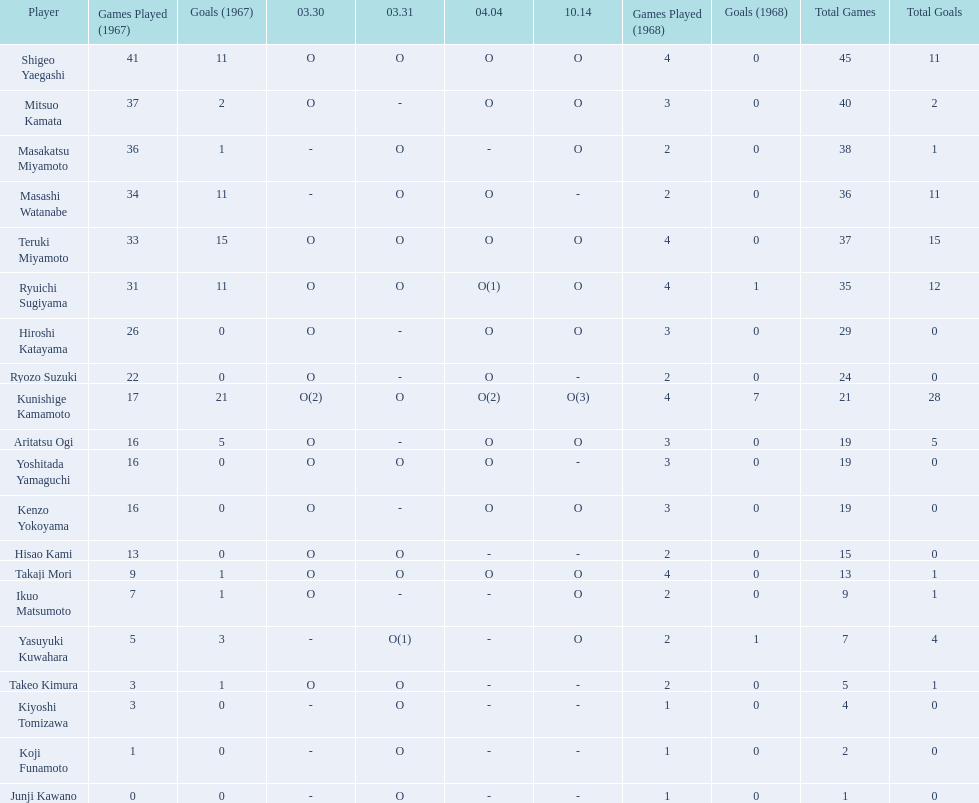How many total did mitsuo kamata have? 40(2). 